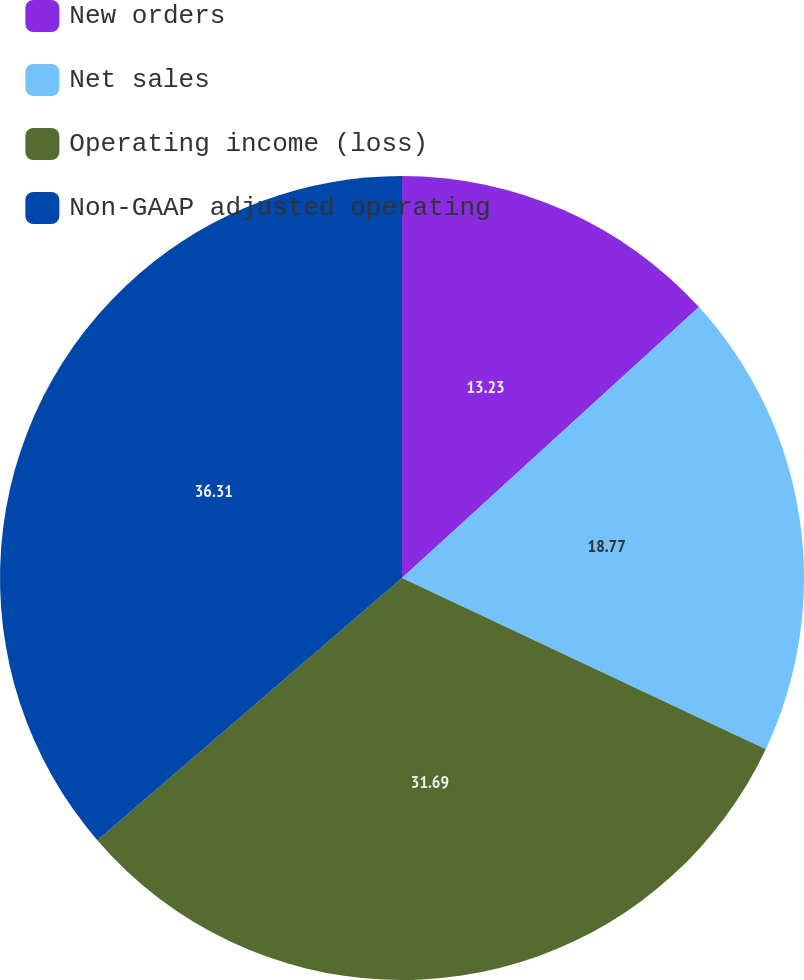Convert chart to OTSL. <chart><loc_0><loc_0><loc_500><loc_500><pie_chart><fcel>New orders<fcel>Net sales<fcel>Operating income (loss)<fcel>Non-GAAP adjusted operating<nl><fcel>13.23%<fcel>18.77%<fcel>31.69%<fcel>36.31%<nl></chart> 